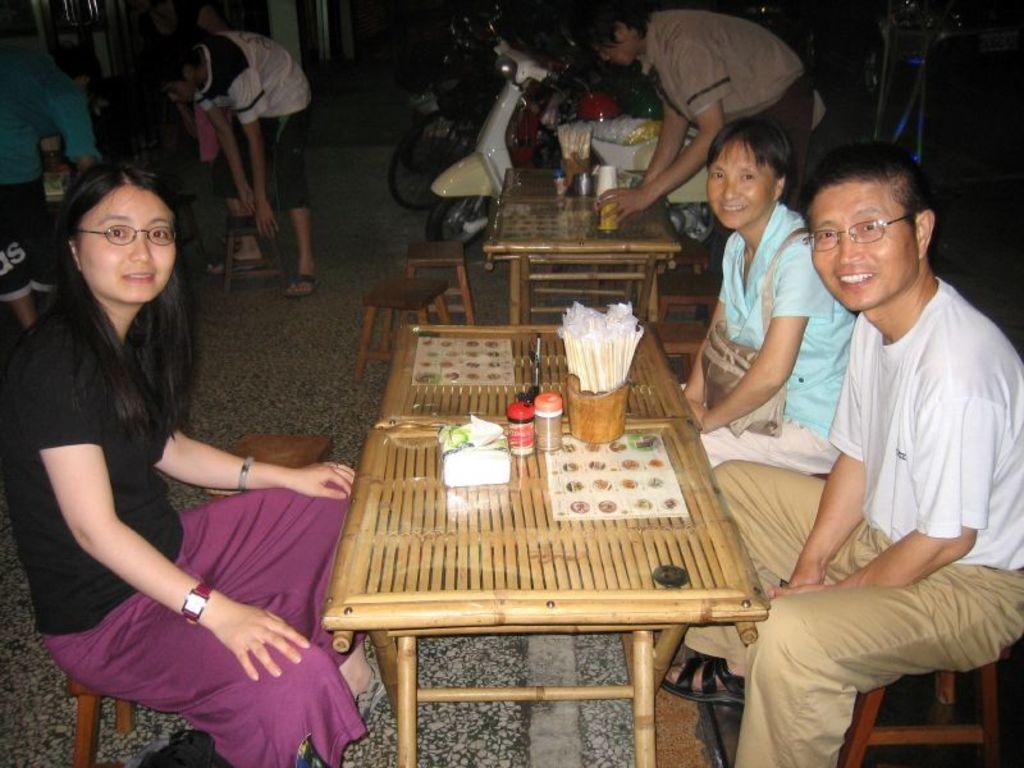Please provide a concise description of this image. On the background of the picture we can see few vehicles and also few persons standing. Here we can see three persons sitting on the chairs in front of a table and on the table we can see few papers, bottles and a tissue paper. Here we can see one person bending and cleaning the table. 